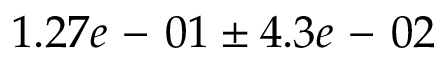Convert formula to latex. <formula><loc_0><loc_0><loc_500><loc_500>1 . 2 7 e - 0 1 \pm 4 . 3 e - 0 2</formula> 